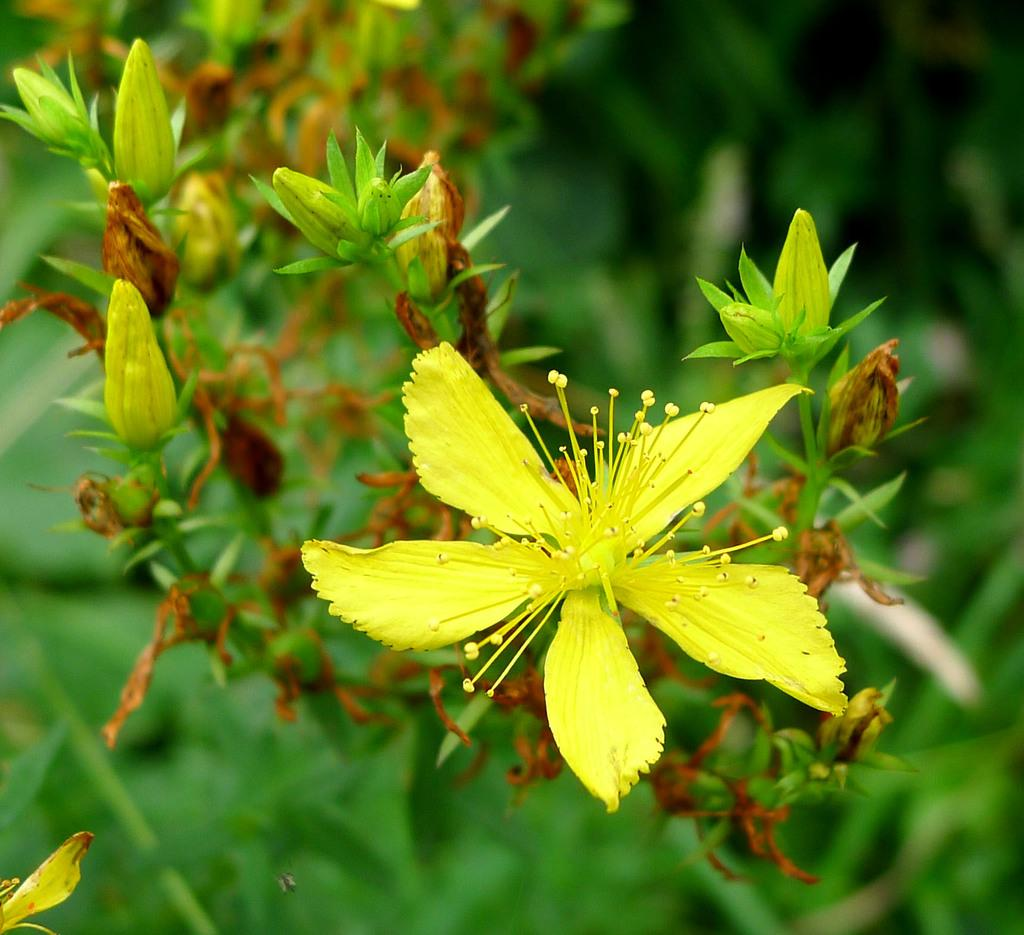What type of plants can be seen in the image? There are flowers in the image. What color are the flowers? The flowers are yellow in color. What other part of the plant is visible in the image? There are green leaves in the image. What color is the background of the image? The background of the image is green. What type of engine can be seen in the image? There is no engine present in the image; it features flowers, green leaves, and a green background. Can you tell me how many ants are crawling on the flowers in the image? There are no ants present in the image; it only features flowers, green leaves, and a green background. 